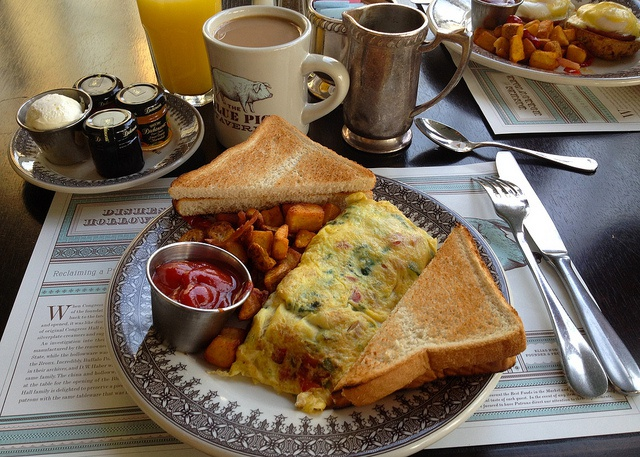Describe the objects in this image and their specific colors. I can see dining table in gray, black, darkgray, and maroon tones, sandwich in gray, olive, tan, and maroon tones, dining table in gray and black tones, cup in gray, tan, and olive tones, and cup in gray, black, and maroon tones in this image. 